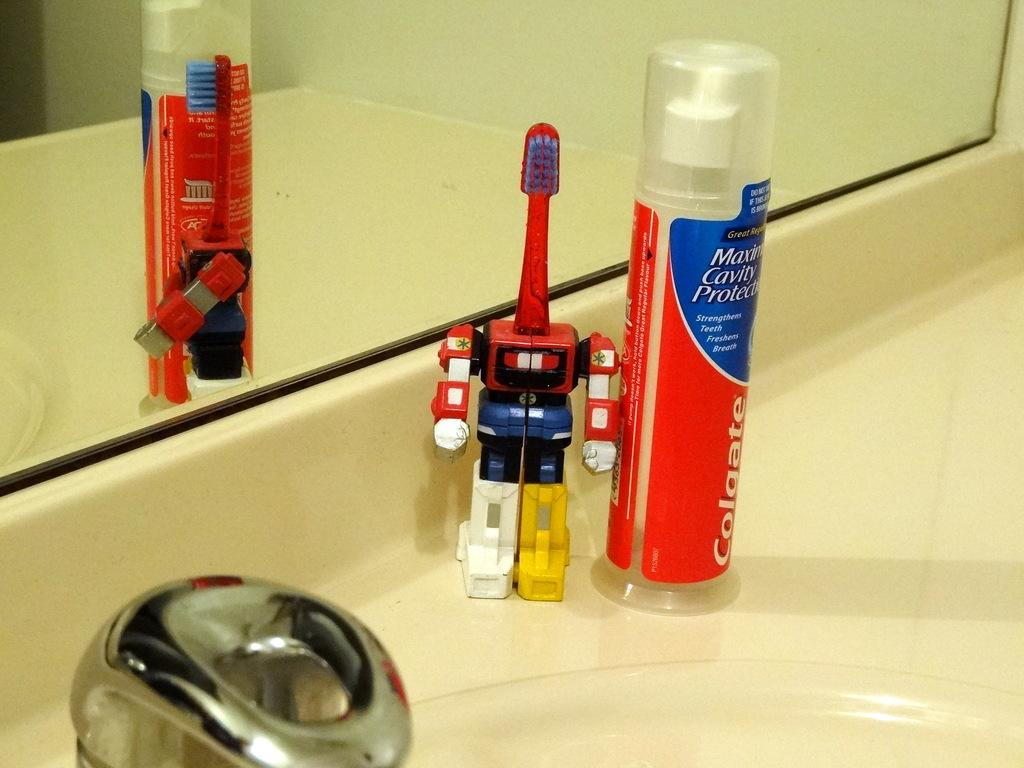Provide a one-sentence caption for the provided image. bathroom countertop with colgate maximum cavity protection toothpaste and red toothbrush in a plastic robot holder. 